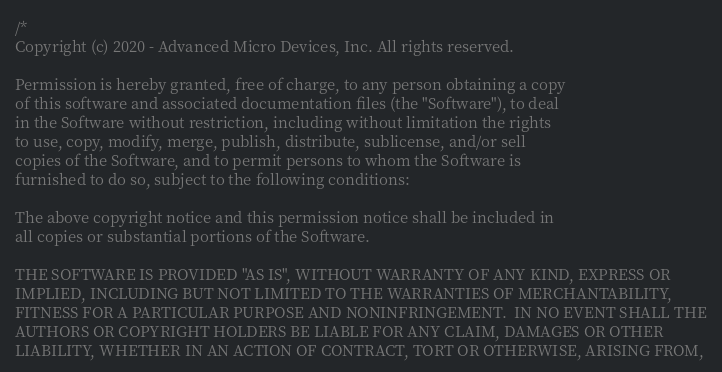Convert code to text. <code><loc_0><loc_0><loc_500><loc_500><_C++_>/*
Copyright (c) 2020 - Advanced Micro Devices, Inc. All rights reserved.

Permission is hereby granted, free of charge, to any person obtaining a copy
of this software and associated documentation files (the "Software"), to deal
in the Software without restriction, including without limitation the rights
to use, copy, modify, merge, publish, distribute, sublicense, and/or sell
copies of the Software, and to permit persons to whom the Software is
furnished to do so, subject to the following conditions:

The above copyright notice and this permission notice shall be included in
all copies or substantial portions of the Software.

THE SOFTWARE IS PROVIDED "AS IS", WITHOUT WARRANTY OF ANY KIND, EXPRESS OR
IMPLIED, INCLUDING BUT NOT LIMITED TO THE WARRANTIES OF MERCHANTABILITY,
FITNESS FOR A PARTICULAR PURPOSE AND NONINFRINGEMENT.  IN NO EVENT SHALL THE
AUTHORS OR COPYRIGHT HOLDERS BE LIABLE FOR ANY CLAIM, DAMAGES OR OTHER
LIABILITY, WHETHER IN AN ACTION OF CONTRACT, TORT OR OTHERWISE, ARISING FROM,</code> 